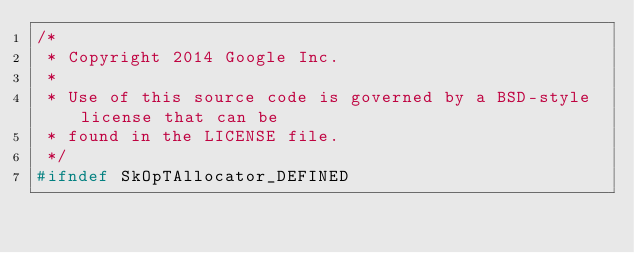<code> <loc_0><loc_0><loc_500><loc_500><_C_>/*
 * Copyright 2014 Google Inc.
 *
 * Use of this source code is governed by a BSD-style license that can be
 * found in the LICENSE file.
 */
#ifndef SkOpTAllocator_DEFINED</code> 